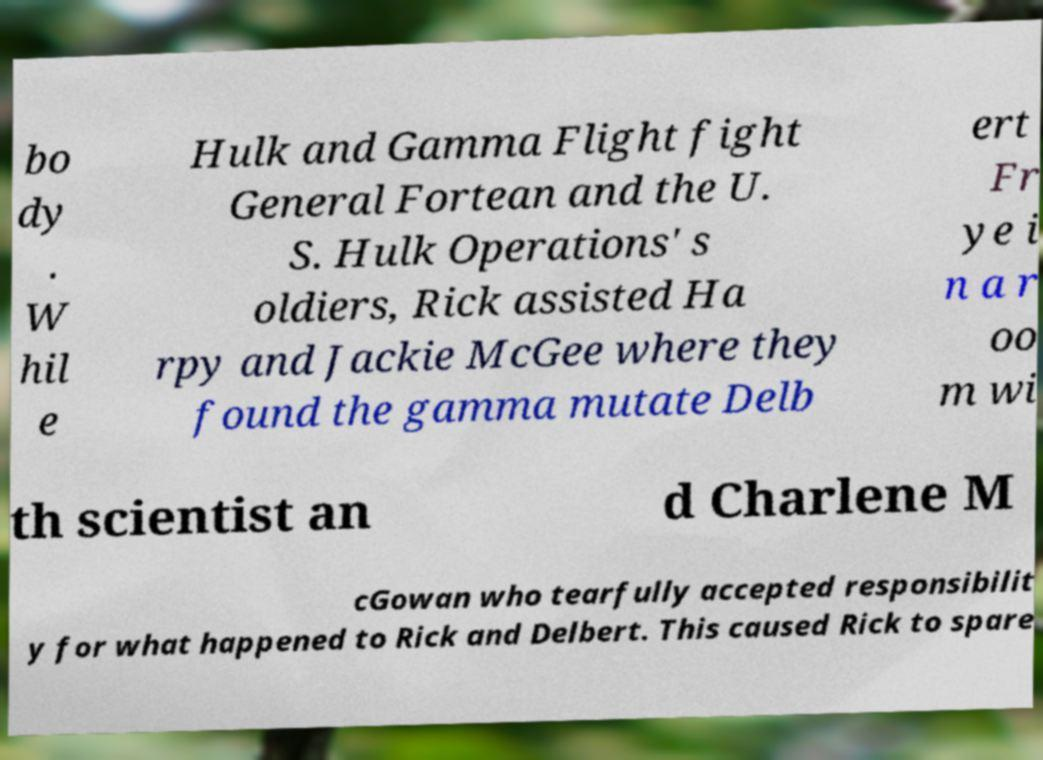Can you accurately transcribe the text from the provided image for me? bo dy . W hil e Hulk and Gamma Flight fight General Fortean and the U. S. Hulk Operations' s oldiers, Rick assisted Ha rpy and Jackie McGee where they found the gamma mutate Delb ert Fr ye i n a r oo m wi th scientist an d Charlene M cGowan who tearfully accepted responsibilit y for what happened to Rick and Delbert. This caused Rick to spare 